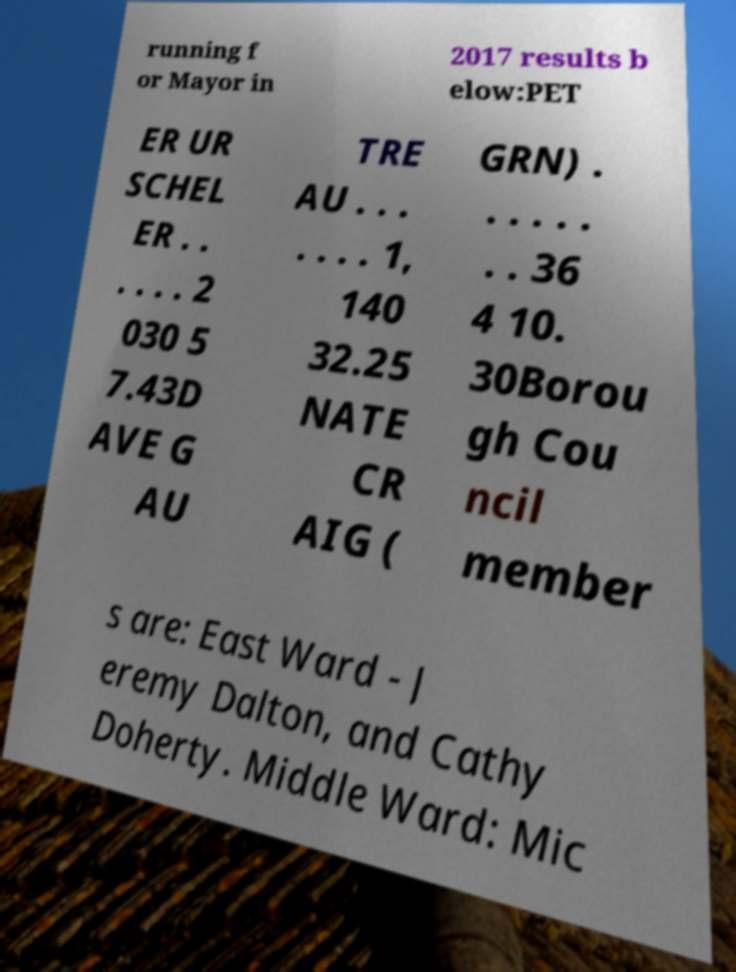Can you read and provide the text displayed in the image?This photo seems to have some interesting text. Can you extract and type it out for me? running f or Mayor in 2017 results b elow:PET ER UR SCHEL ER . . . . . . 2 030 5 7.43D AVE G AU TRE AU . . . . . . . 1, 140 32.25 NATE CR AIG ( GRN) . . . . . . . . 36 4 10. 30Borou gh Cou ncil member s are: East Ward - J eremy Dalton, and Cathy Doherty. Middle Ward: Mic 